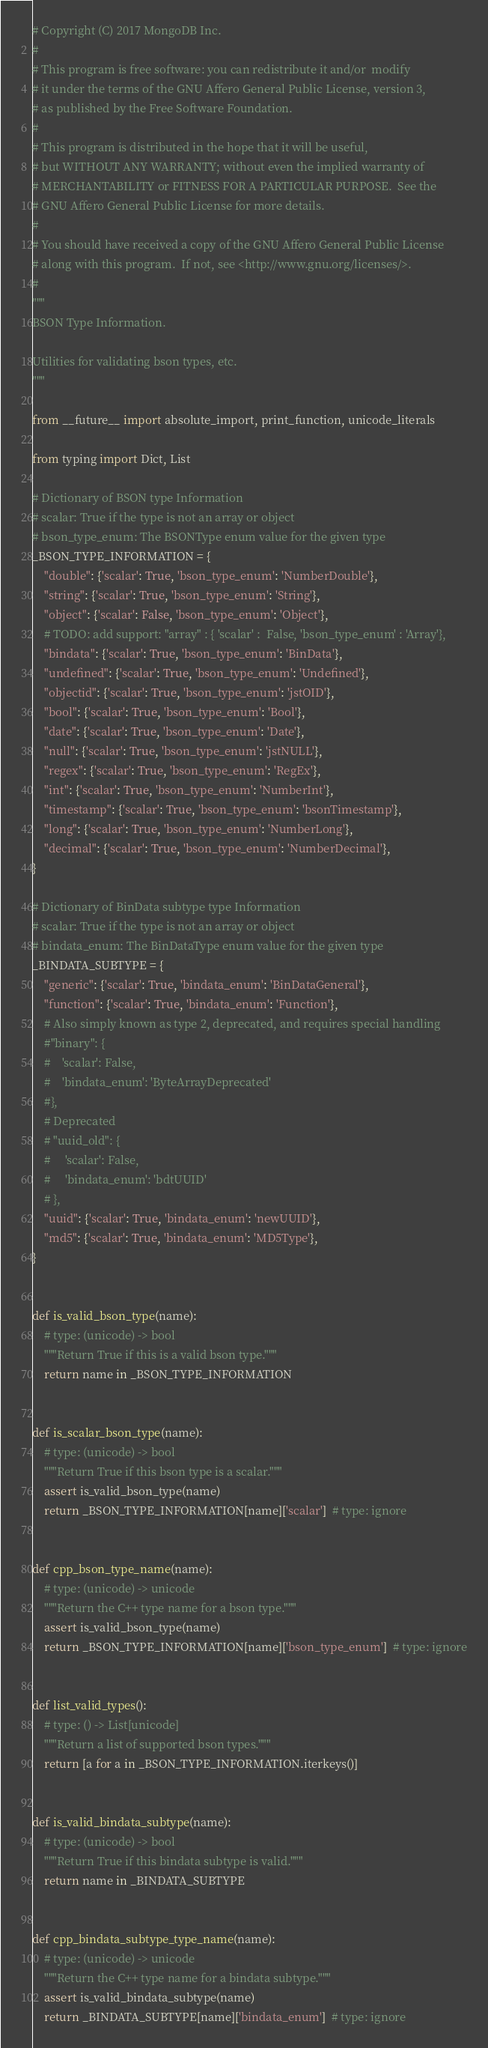<code> <loc_0><loc_0><loc_500><loc_500><_Python_># Copyright (C) 2017 MongoDB Inc.
#
# This program is free software: you can redistribute it and/or  modify
# it under the terms of the GNU Affero General Public License, version 3,
# as published by the Free Software Foundation.
#
# This program is distributed in the hope that it will be useful,
# but WITHOUT ANY WARRANTY; without even the implied warranty of
# MERCHANTABILITY or FITNESS FOR A PARTICULAR PURPOSE.  See the
# GNU Affero General Public License for more details.
#
# You should have received a copy of the GNU Affero General Public License
# along with this program.  If not, see <http://www.gnu.org/licenses/>.
#
"""
BSON Type Information.

Utilities for validating bson types, etc.
"""

from __future__ import absolute_import, print_function, unicode_literals

from typing import Dict, List

# Dictionary of BSON type Information
# scalar: True if the type is not an array or object
# bson_type_enum: The BSONType enum value for the given type
_BSON_TYPE_INFORMATION = {
    "double": {'scalar': True, 'bson_type_enum': 'NumberDouble'},
    "string": {'scalar': True, 'bson_type_enum': 'String'},
    "object": {'scalar': False, 'bson_type_enum': 'Object'},
    # TODO: add support: "array" : { 'scalar' :  False, 'bson_type_enum' : 'Array'},
    "bindata": {'scalar': True, 'bson_type_enum': 'BinData'},
    "undefined": {'scalar': True, 'bson_type_enum': 'Undefined'},
    "objectid": {'scalar': True, 'bson_type_enum': 'jstOID'},
    "bool": {'scalar': True, 'bson_type_enum': 'Bool'},
    "date": {'scalar': True, 'bson_type_enum': 'Date'},
    "null": {'scalar': True, 'bson_type_enum': 'jstNULL'},
    "regex": {'scalar': True, 'bson_type_enum': 'RegEx'},
    "int": {'scalar': True, 'bson_type_enum': 'NumberInt'},
    "timestamp": {'scalar': True, 'bson_type_enum': 'bsonTimestamp'},
    "long": {'scalar': True, 'bson_type_enum': 'NumberLong'},
    "decimal": {'scalar': True, 'bson_type_enum': 'NumberDecimal'},
}

# Dictionary of BinData subtype type Information
# scalar: True if the type is not an array or object
# bindata_enum: The BinDataType enum value for the given type
_BINDATA_SUBTYPE = {
    "generic": {'scalar': True, 'bindata_enum': 'BinDataGeneral'},
    "function": {'scalar': True, 'bindata_enum': 'Function'},
    # Also simply known as type 2, deprecated, and requires special handling
    #"binary": {
    #    'scalar': False,
    #    'bindata_enum': 'ByteArrayDeprecated'
    #},
    # Deprecated
    # "uuid_old": {
    #     'scalar': False,
    #     'bindata_enum': 'bdtUUID'
    # },
    "uuid": {'scalar': True, 'bindata_enum': 'newUUID'},
    "md5": {'scalar': True, 'bindata_enum': 'MD5Type'},
}


def is_valid_bson_type(name):
    # type: (unicode) -> bool
    """Return True if this is a valid bson type."""
    return name in _BSON_TYPE_INFORMATION


def is_scalar_bson_type(name):
    # type: (unicode) -> bool
    """Return True if this bson type is a scalar."""
    assert is_valid_bson_type(name)
    return _BSON_TYPE_INFORMATION[name]['scalar']  # type: ignore


def cpp_bson_type_name(name):
    # type: (unicode) -> unicode
    """Return the C++ type name for a bson type."""
    assert is_valid_bson_type(name)
    return _BSON_TYPE_INFORMATION[name]['bson_type_enum']  # type: ignore


def list_valid_types():
    # type: () -> List[unicode]
    """Return a list of supported bson types."""
    return [a for a in _BSON_TYPE_INFORMATION.iterkeys()]


def is_valid_bindata_subtype(name):
    # type: (unicode) -> bool
    """Return True if this bindata subtype is valid."""
    return name in _BINDATA_SUBTYPE


def cpp_bindata_subtype_type_name(name):
    # type: (unicode) -> unicode
    """Return the C++ type name for a bindata subtype."""
    assert is_valid_bindata_subtype(name)
    return _BINDATA_SUBTYPE[name]['bindata_enum']  # type: ignore
</code> 